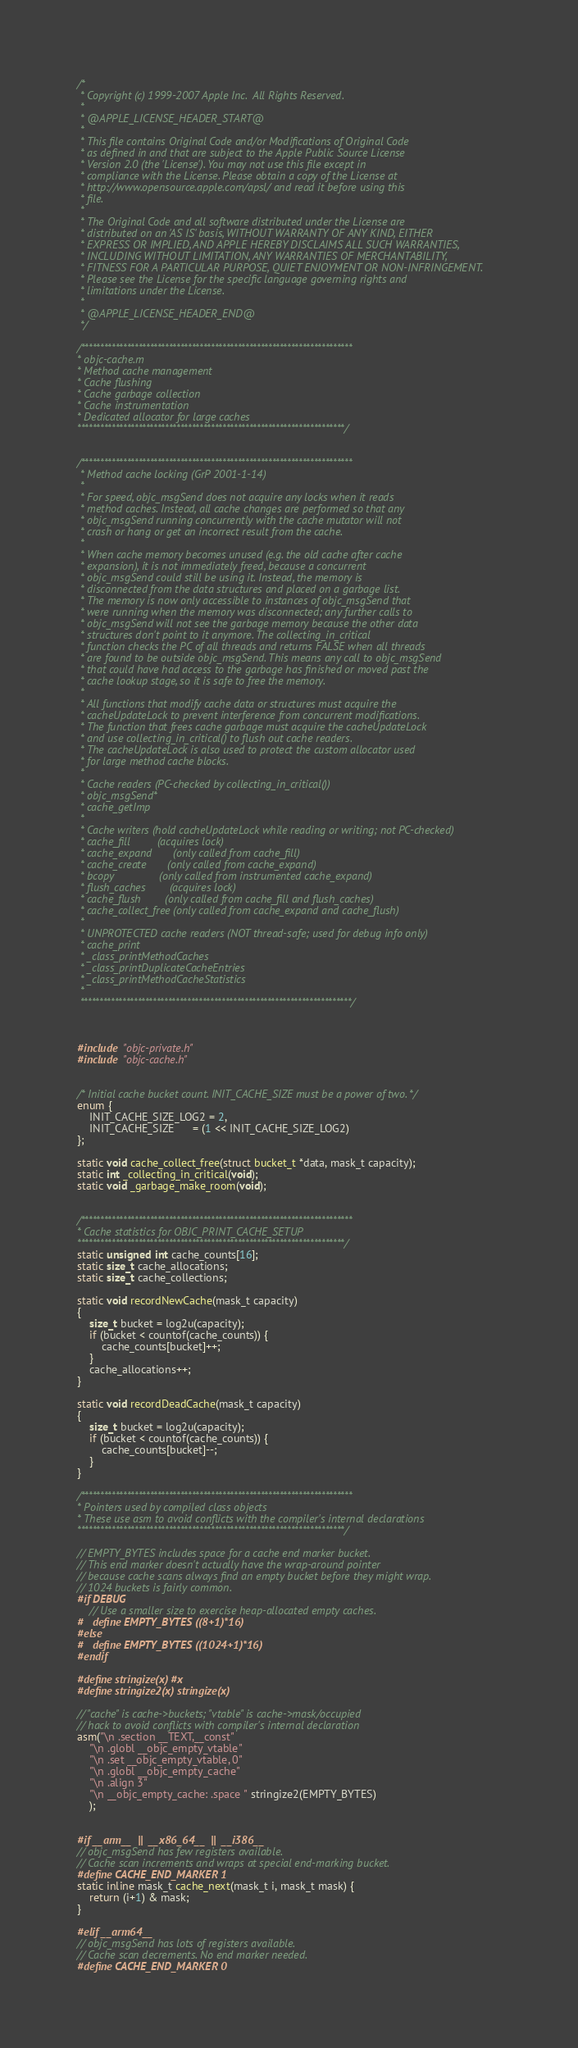<code> <loc_0><loc_0><loc_500><loc_500><_ObjectiveC_>/*
 * Copyright (c) 1999-2007 Apple Inc.  All Rights Reserved.
 * 
 * @APPLE_LICENSE_HEADER_START@
 * 
 * This file contains Original Code and/or Modifications of Original Code
 * as defined in and that are subject to the Apple Public Source License
 * Version 2.0 (the 'License'). You may not use this file except in
 * compliance with the License. Please obtain a copy of the License at
 * http://www.opensource.apple.com/apsl/ and read it before using this
 * file.
 * 
 * The Original Code and all software distributed under the License are
 * distributed on an 'AS IS' basis, WITHOUT WARRANTY OF ANY KIND, EITHER
 * EXPRESS OR IMPLIED, AND APPLE HEREBY DISCLAIMS ALL SUCH WARRANTIES,
 * INCLUDING WITHOUT LIMITATION, ANY WARRANTIES OF MERCHANTABILITY,
 * FITNESS FOR A PARTICULAR PURPOSE, QUIET ENJOYMENT OR NON-INFRINGEMENT.
 * Please see the License for the specific language governing rights and
 * limitations under the License.
 * 
 * @APPLE_LICENSE_HEADER_END@
 */

/***********************************************************************
* objc-cache.m
* Method cache management
* Cache flushing
* Cache garbage collection
* Cache instrumentation
* Dedicated allocator for large caches
**********************************************************************/


/***********************************************************************
 * Method cache locking (GrP 2001-1-14)
 *
 * For speed, objc_msgSend does not acquire any locks when it reads 
 * method caches. Instead, all cache changes are performed so that any 
 * objc_msgSend running concurrently with the cache mutator will not 
 * crash or hang or get an incorrect result from the cache. 
 *
 * When cache memory becomes unused (e.g. the old cache after cache 
 * expansion), it is not immediately freed, because a concurrent 
 * objc_msgSend could still be using it. Instead, the memory is 
 * disconnected from the data structures and placed on a garbage list. 
 * The memory is now only accessible to instances of objc_msgSend that 
 * were running when the memory was disconnected; any further calls to 
 * objc_msgSend will not see the garbage memory because the other data 
 * structures don't point to it anymore. The collecting_in_critical
 * function checks the PC of all threads and returns FALSE when all threads 
 * are found to be outside objc_msgSend. This means any call to objc_msgSend 
 * that could have had access to the garbage has finished or moved past the 
 * cache lookup stage, so it is safe to free the memory.
 *
 * All functions that modify cache data or structures must acquire the 
 * cacheUpdateLock to prevent interference from concurrent modifications.
 * The function that frees cache garbage must acquire the cacheUpdateLock 
 * and use collecting_in_critical() to flush out cache readers.
 * The cacheUpdateLock is also used to protect the custom allocator used 
 * for large method cache blocks.
 *
 * Cache readers (PC-checked by collecting_in_critical())
 * objc_msgSend*
 * cache_getImp
 *
 * Cache writers (hold cacheUpdateLock while reading or writing; not PC-checked)
 * cache_fill         (acquires lock)
 * cache_expand       (only called from cache_fill)
 * cache_create       (only called from cache_expand)
 * bcopy               (only called from instrumented cache_expand)
 * flush_caches        (acquires lock)
 * cache_flush        (only called from cache_fill and flush_caches)
 * cache_collect_free (only called from cache_expand and cache_flush)
 *
 * UNPROTECTED cache readers (NOT thread-safe; used for debug info only)
 * cache_print
 * _class_printMethodCaches
 * _class_printDuplicateCacheEntries
 * _class_printMethodCacheStatistics
 *
 ***********************************************************************/



#include "objc-private.h"
#include "objc-cache.h"


/* Initial cache bucket count. INIT_CACHE_SIZE must be a power of two. */
enum {
    INIT_CACHE_SIZE_LOG2 = 2,
    INIT_CACHE_SIZE      = (1 << INIT_CACHE_SIZE_LOG2)
};

static void cache_collect_free(struct bucket_t *data, mask_t capacity);
static int _collecting_in_critical(void);
static void _garbage_make_room(void);


/***********************************************************************
* Cache statistics for OBJC_PRINT_CACHE_SETUP
**********************************************************************/
static unsigned int cache_counts[16];
static size_t cache_allocations;
static size_t cache_collections;

static void recordNewCache(mask_t capacity)
{
    size_t bucket = log2u(capacity);
    if (bucket < countof(cache_counts)) {
        cache_counts[bucket]++;
    }
    cache_allocations++;
}

static void recordDeadCache(mask_t capacity)
{
    size_t bucket = log2u(capacity);
    if (bucket < countof(cache_counts)) {
        cache_counts[bucket]--;
    }
}

/***********************************************************************
* Pointers used by compiled class objects
* These use asm to avoid conflicts with the compiler's internal declarations
**********************************************************************/

// EMPTY_BYTES includes space for a cache end marker bucket.
// This end marker doesn't actually have the wrap-around pointer 
// because cache scans always find an empty bucket before they might wrap.
// 1024 buckets is fairly common.
#if DEBUG
    // Use a smaller size to exercise heap-allocated empty caches.
#   define EMPTY_BYTES ((8+1)*16)
#else
#   define EMPTY_BYTES ((1024+1)*16)
#endif

#define stringize(x) #x
#define stringize2(x) stringize(x)

// "cache" is cache->buckets; "vtable" is cache->mask/occupied
// hack to avoid conflicts with compiler's internal declaration
asm("\n .section __TEXT,__const"
    "\n .globl __objc_empty_vtable"
    "\n .set __objc_empty_vtable, 0"
    "\n .globl __objc_empty_cache"
    "\n .align 3"
    "\n __objc_empty_cache: .space " stringize2(EMPTY_BYTES)
    );


#if __arm__  ||  __x86_64__  ||  __i386__
// objc_msgSend has few registers available.
// Cache scan increments and wraps at special end-marking bucket.
#define CACHE_END_MARKER 1
static inline mask_t cache_next(mask_t i, mask_t mask) {
    return (i+1) & mask;
}

#elif __arm64__
// objc_msgSend has lots of registers available.
// Cache scan decrements. No end marker needed.
#define CACHE_END_MARKER 0</code> 